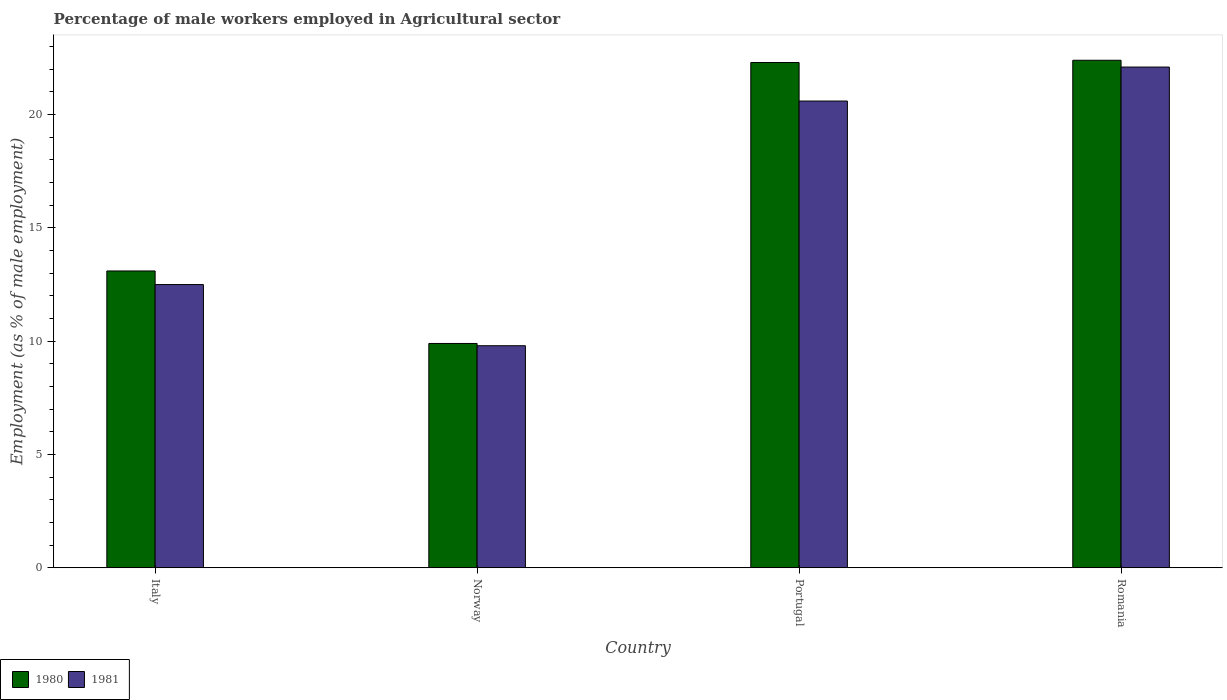How many groups of bars are there?
Provide a short and direct response. 4. How many bars are there on the 1st tick from the left?
Ensure brevity in your answer.  2. In how many cases, is the number of bars for a given country not equal to the number of legend labels?
Your response must be concise. 0. What is the percentage of male workers employed in Agricultural sector in 1981 in Romania?
Make the answer very short. 22.1. Across all countries, what is the maximum percentage of male workers employed in Agricultural sector in 1980?
Your answer should be compact. 22.4. Across all countries, what is the minimum percentage of male workers employed in Agricultural sector in 1981?
Your answer should be very brief. 9.8. In which country was the percentage of male workers employed in Agricultural sector in 1981 maximum?
Ensure brevity in your answer.  Romania. In which country was the percentage of male workers employed in Agricultural sector in 1981 minimum?
Offer a very short reply. Norway. What is the total percentage of male workers employed in Agricultural sector in 1981 in the graph?
Give a very brief answer. 65. What is the difference between the percentage of male workers employed in Agricultural sector in 1981 in Norway and that in Portugal?
Give a very brief answer. -10.8. What is the difference between the percentage of male workers employed in Agricultural sector in 1981 in Romania and the percentage of male workers employed in Agricultural sector in 1980 in Norway?
Offer a very short reply. 12.2. What is the average percentage of male workers employed in Agricultural sector in 1981 per country?
Offer a very short reply. 16.25. What is the difference between the percentage of male workers employed in Agricultural sector of/in 1981 and percentage of male workers employed in Agricultural sector of/in 1980 in Norway?
Give a very brief answer. -0.1. In how many countries, is the percentage of male workers employed in Agricultural sector in 1980 greater than 15 %?
Your response must be concise. 2. What is the ratio of the percentage of male workers employed in Agricultural sector in 1981 in Italy to that in Romania?
Keep it short and to the point. 0.57. Is the percentage of male workers employed in Agricultural sector in 1981 in Italy less than that in Norway?
Give a very brief answer. No. What is the difference between the highest and the second highest percentage of male workers employed in Agricultural sector in 1980?
Your answer should be very brief. -9.3. What is the difference between the highest and the lowest percentage of male workers employed in Agricultural sector in 1980?
Ensure brevity in your answer.  12.5. In how many countries, is the percentage of male workers employed in Agricultural sector in 1981 greater than the average percentage of male workers employed in Agricultural sector in 1981 taken over all countries?
Offer a very short reply. 2. What does the 2nd bar from the left in Portugal represents?
Your answer should be compact. 1981. How many bars are there?
Keep it short and to the point. 8. How many countries are there in the graph?
Give a very brief answer. 4. What is the difference between two consecutive major ticks on the Y-axis?
Offer a very short reply. 5. How are the legend labels stacked?
Offer a terse response. Horizontal. What is the title of the graph?
Your response must be concise. Percentage of male workers employed in Agricultural sector. What is the label or title of the X-axis?
Your answer should be compact. Country. What is the label or title of the Y-axis?
Provide a succinct answer. Employment (as % of male employment). What is the Employment (as % of male employment) in 1980 in Italy?
Your answer should be compact. 13.1. What is the Employment (as % of male employment) of 1981 in Italy?
Your answer should be compact. 12.5. What is the Employment (as % of male employment) of 1980 in Norway?
Offer a very short reply. 9.9. What is the Employment (as % of male employment) of 1981 in Norway?
Make the answer very short. 9.8. What is the Employment (as % of male employment) in 1980 in Portugal?
Make the answer very short. 22.3. What is the Employment (as % of male employment) of 1981 in Portugal?
Offer a very short reply. 20.6. What is the Employment (as % of male employment) in 1980 in Romania?
Your response must be concise. 22.4. What is the Employment (as % of male employment) of 1981 in Romania?
Provide a short and direct response. 22.1. Across all countries, what is the maximum Employment (as % of male employment) of 1980?
Your response must be concise. 22.4. Across all countries, what is the maximum Employment (as % of male employment) in 1981?
Provide a succinct answer. 22.1. Across all countries, what is the minimum Employment (as % of male employment) of 1980?
Keep it short and to the point. 9.9. Across all countries, what is the minimum Employment (as % of male employment) in 1981?
Give a very brief answer. 9.8. What is the total Employment (as % of male employment) of 1980 in the graph?
Give a very brief answer. 67.7. What is the difference between the Employment (as % of male employment) in 1980 in Italy and that in Norway?
Give a very brief answer. 3.2. What is the difference between the Employment (as % of male employment) in 1981 in Italy and that in Norway?
Make the answer very short. 2.7. What is the difference between the Employment (as % of male employment) of 1980 in Italy and that in Portugal?
Your answer should be very brief. -9.2. What is the difference between the Employment (as % of male employment) of 1980 in Italy and that in Romania?
Make the answer very short. -9.3. What is the difference between the Employment (as % of male employment) of 1981 in Norway and that in Portugal?
Provide a succinct answer. -10.8. What is the difference between the Employment (as % of male employment) of 1980 in Portugal and that in Romania?
Offer a terse response. -0.1. What is the difference between the Employment (as % of male employment) in 1980 in Italy and the Employment (as % of male employment) in 1981 in Portugal?
Your answer should be compact. -7.5. What is the difference between the Employment (as % of male employment) of 1980 in Italy and the Employment (as % of male employment) of 1981 in Romania?
Make the answer very short. -9. What is the difference between the Employment (as % of male employment) of 1980 in Norway and the Employment (as % of male employment) of 1981 in Portugal?
Make the answer very short. -10.7. What is the average Employment (as % of male employment) of 1980 per country?
Give a very brief answer. 16.93. What is the average Employment (as % of male employment) of 1981 per country?
Ensure brevity in your answer.  16.25. What is the difference between the Employment (as % of male employment) in 1980 and Employment (as % of male employment) in 1981 in Portugal?
Keep it short and to the point. 1.7. What is the ratio of the Employment (as % of male employment) of 1980 in Italy to that in Norway?
Your response must be concise. 1.32. What is the ratio of the Employment (as % of male employment) in 1981 in Italy to that in Norway?
Provide a succinct answer. 1.28. What is the ratio of the Employment (as % of male employment) in 1980 in Italy to that in Portugal?
Provide a succinct answer. 0.59. What is the ratio of the Employment (as % of male employment) in 1981 in Italy to that in Portugal?
Your answer should be compact. 0.61. What is the ratio of the Employment (as % of male employment) of 1980 in Italy to that in Romania?
Offer a terse response. 0.58. What is the ratio of the Employment (as % of male employment) in 1981 in Italy to that in Romania?
Provide a succinct answer. 0.57. What is the ratio of the Employment (as % of male employment) of 1980 in Norway to that in Portugal?
Offer a very short reply. 0.44. What is the ratio of the Employment (as % of male employment) of 1981 in Norway to that in Portugal?
Keep it short and to the point. 0.48. What is the ratio of the Employment (as % of male employment) in 1980 in Norway to that in Romania?
Offer a terse response. 0.44. What is the ratio of the Employment (as % of male employment) of 1981 in Norway to that in Romania?
Keep it short and to the point. 0.44. What is the ratio of the Employment (as % of male employment) in 1981 in Portugal to that in Romania?
Give a very brief answer. 0.93. What is the difference between the highest and the second highest Employment (as % of male employment) of 1981?
Make the answer very short. 1.5. What is the difference between the highest and the lowest Employment (as % of male employment) of 1980?
Your response must be concise. 12.5. 